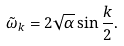Convert formula to latex. <formula><loc_0><loc_0><loc_500><loc_500>\tilde { \omega } _ { k } = 2 \sqrt { \alpha } \sin { \frac { k } { 2 } } .</formula> 